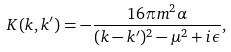<formula> <loc_0><loc_0><loc_500><loc_500>K ( k , k ^ { \prime } ) = - \frac { 1 6 \pi m ^ { 2 } \alpha } { ( k - k ^ { \prime } ) ^ { 2 } - \mu ^ { 2 } + i \epsilon } ,</formula> 